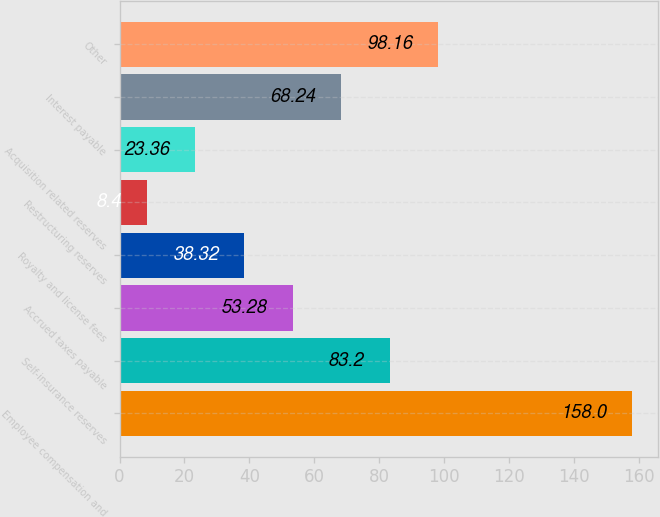<chart> <loc_0><loc_0><loc_500><loc_500><bar_chart><fcel>Employee compensation and<fcel>Self-insurance reserves<fcel>Accrued taxes payable<fcel>Royalty and license fees<fcel>Restructuring reserves<fcel>Acquisition related reserves<fcel>Interest payable<fcel>Other<nl><fcel>158<fcel>83.2<fcel>53.28<fcel>38.32<fcel>8.4<fcel>23.36<fcel>68.24<fcel>98.16<nl></chart> 